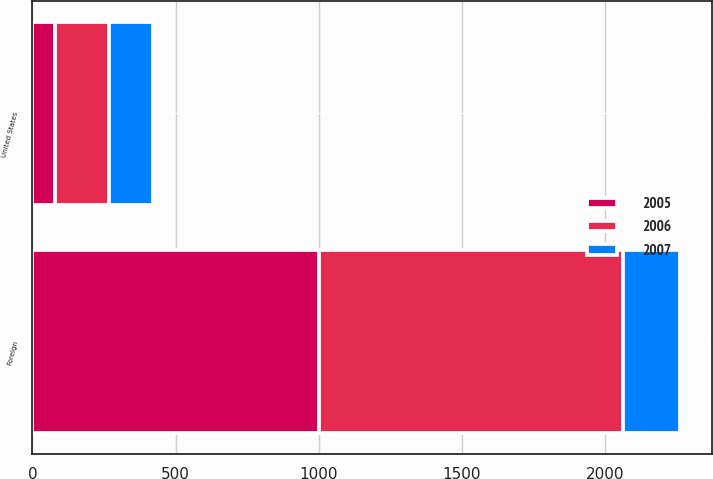Convert chart. <chart><loc_0><loc_0><loc_500><loc_500><stacked_bar_chart><ecel><fcel>United States<fcel>Foreign<nl><fcel>2007<fcel>155<fcel>197<nl><fcel>2006<fcel>188<fcel>1062<nl><fcel>2005<fcel>78<fcel>1002<nl></chart> 